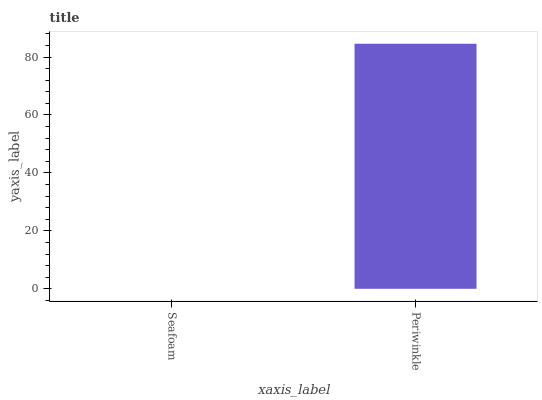Is Seafoam the minimum?
Answer yes or no. Yes. Is Periwinkle the maximum?
Answer yes or no. Yes. Is Periwinkle the minimum?
Answer yes or no. No. Is Periwinkle greater than Seafoam?
Answer yes or no. Yes. Is Seafoam less than Periwinkle?
Answer yes or no. Yes. Is Seafoam greater than Periwinkle?
Answer yes or no. No. Is Periwinkle less than Seafoam?
Answer yes or no. No. Is Periwinkle the high median?
Answer yes or no. Yes. Is Seafoam the low median?
Answer yes or no. Yes. Is Seafoam the high median?
Answer yes or no. No. Is Periwinkle the low median?
Answer yes or no. No. 